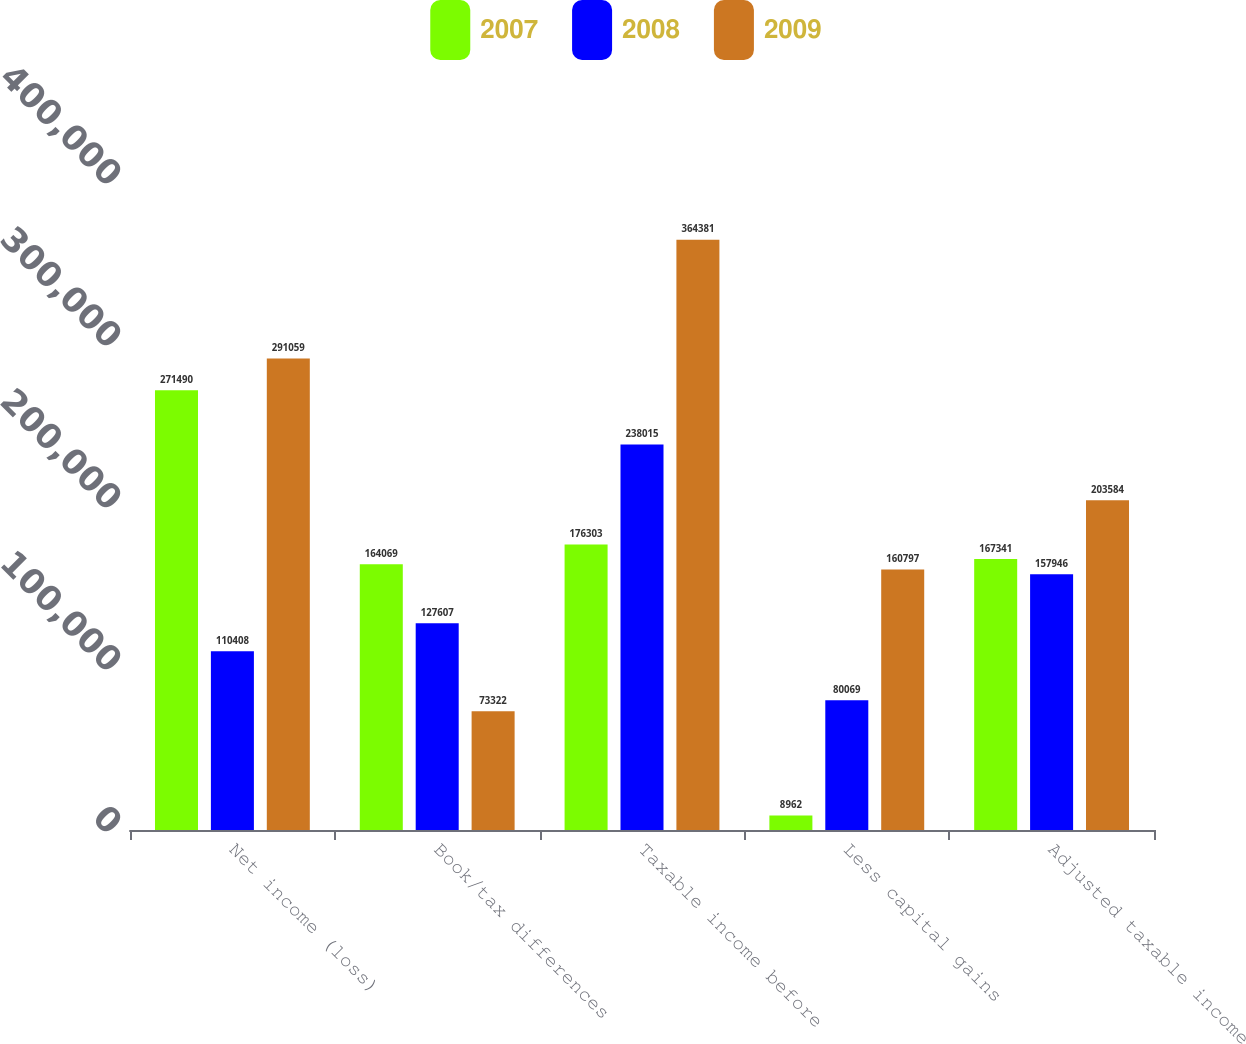<chart> <loc_0><loc_0><loc_500><loc_500><stacked_bar_chart><ecel><fcel>Net income (loss)<fcel>Book/tax differences<fcel>Taxable income before<fcel>Less capital gains<fcel>Adjusted taxable income<nl><fcel>2007<fcel>271490<fcel>164069<fcel>176303<fcel>8962<fcel>167341<nl><fcel>2008<fcel>110408<fcel>127607<fcel>238015<fcel>80069<fcel>157946<nl><fcel>2009<fcel>291059<fcel>73322<fcel>364381<fcel>160797<fcel>203584<nl></chart> 